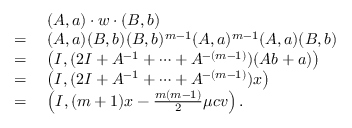Convert formula to latex. <formula><loc_0><loc_0><loc_500><loc_500>\begin{array} { r l } & { ( A , a ) \cdot w \cdot ( B , b ) } \\ { = \, } & { ( A , a ) ( B , b ) ( B , b ) ^ { m - 1 } ( A , a ) ^ { m - 1 } ( A , a ) ( B , b ) } \\ { = \, } & { \left ( I , ( 2 I + A ^ { - 1 } + \cdots + A ^ { - ( m - 1 ) } ) ( A b + a ) \right ) } \\ { = \, } & { \left ( I , ( 2 I + A ^ { - 1 } + \cdots + A ^ { - ( m - 1 ) } ) x \right ) } \\ { = \, } & { \left ( I , ( m + 1 ) x - \frac { m ( m - 1 ) } { 2 } \mu c v \right ) . } \end{array}</formula> 